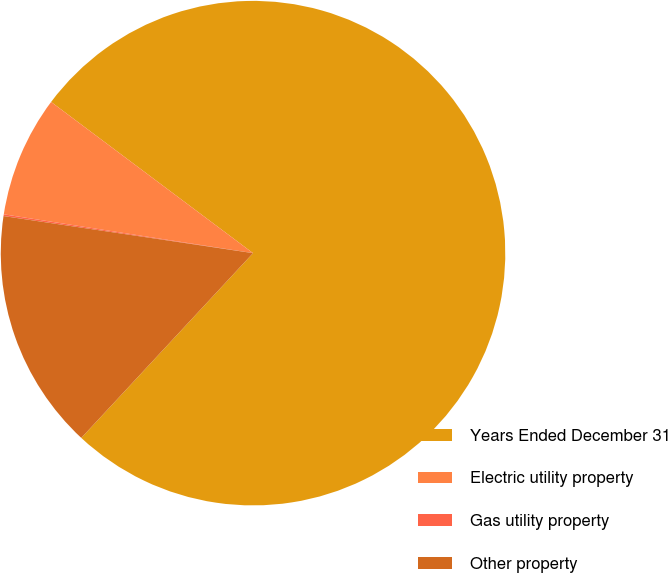Convert chart to OTSL. <chart><loc_0><loc_0><loc_500><loc_500><pie_chart><fcel>Years Ended December 31<fcel>Electric utility property<fcel>Gas utility property<fcel>Other property<nl><fcel>76.69%<fcel>7.77%<fcel>0.11%<fcel>15.43%<nl></chart> 